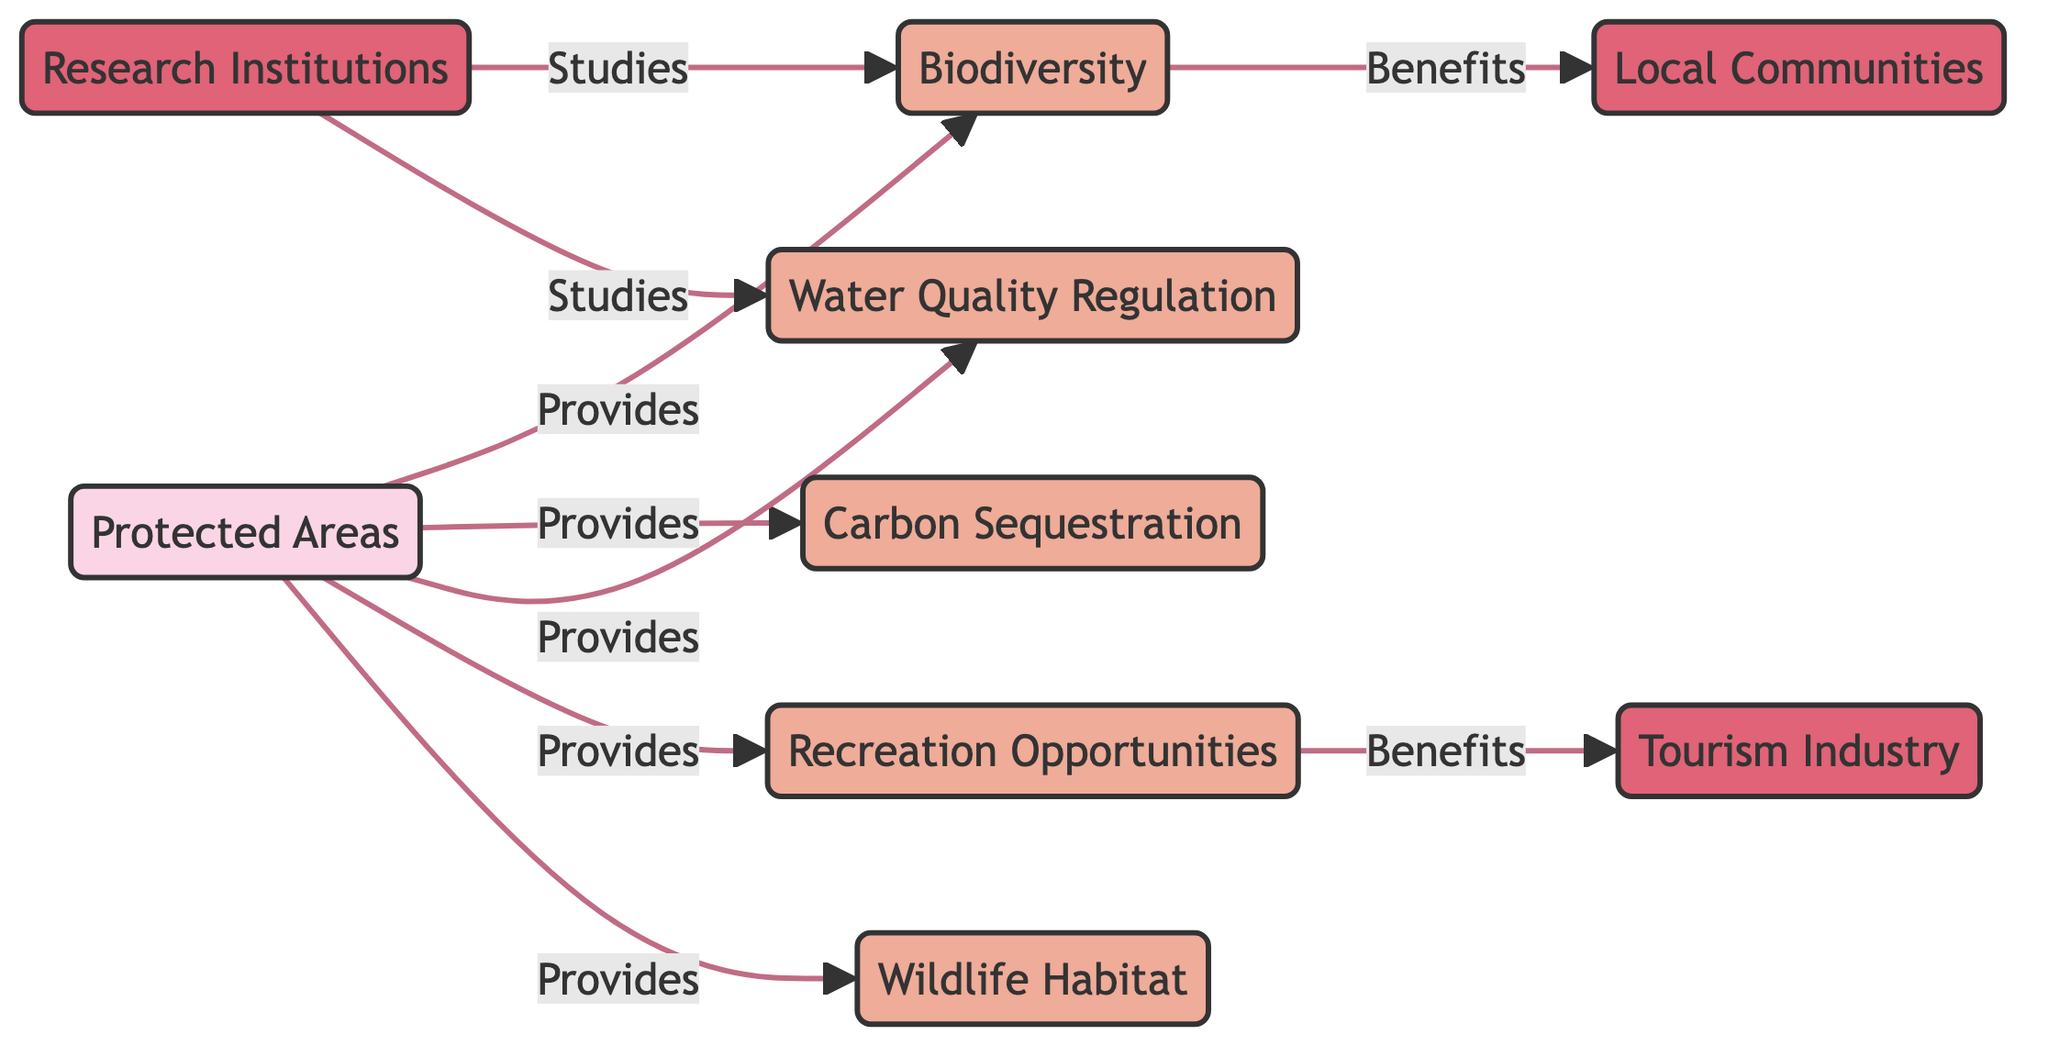What are the services provided by Protected Areas? The diagram shows that Protected Areas provide five services: Biodiversity, Carbon Sequestration, Water Quality Regulation, Recreation Opportunities, and Wildlife Habitat.
Answer: Biodiversity, Carbon Sequestration, Water Quality Regulation, Recreation Opportunities, Wildlife Habitat How many stakeholders are represented in the diagram? There are three stakeholders represented in the diagram: Local Communities, Tourism Industry, and Research Institutions.
Answer: 3 What does Biodiversity benefit? The diagram indicates that Biodiversity benefits Local Communities.
Answer: Local Communities Which service is linked to the Tourism Industry? The diagram shows that Recreation Opportunities are the service linked to the Tourism Industry.
Answer: Recreation Opportunities How many services are connected to Protected Areas? There are five services connected to Protected Areas according to the diagram.
Answer: 5 Which nodes have a direct relationship with Research Institutions? The diagram indicates that Research Institutions have direct relationships with Biodiversity and Water Quality Regulation.
Answer: Biodiversity, Water Quality Regulation What type of relationship is shown between Protected Areas and Biodiversity? The diagram illustrates that the relationship is one where Protected Areas provide Biodiversity.
Answer: Provides Which service is directly linked to two stakeholders? The Recreation Opportunities service is directly linked to the Tourism Industry stakeholder.
Answer: Tourism Industry Is there any stakeholder benefiting from Carbon Sequestration? The diagram does not show any stakeholder benefiting from Carbon Sequestration, as there are no direct edges leading to stakeholders from that service.
Answer: No What is the primary role of Research Institutions in relation to the services? Research Institutions study the services of Biodiversity and Water Quality Regulation according to the diagram.
Answer: Studies 